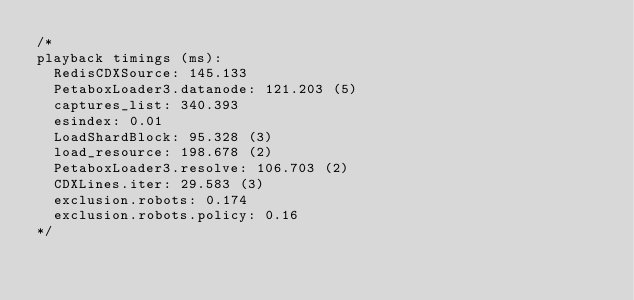Convert code to text. <code><loc_0><loc_0><loc_500><loc_500><_CSS_>/*
playback timings (ms):
  RedisCDXSource: 145.133
  PetaboxLoader3.datanode: 121.203 (5)
  captures_list: 340.393
  esindex: 0.01
  LoadShardBlock: 95.328 (3)
  load_resource: 198.678 (2)
  PetaboxLoader3.resolve: 106.703 (2)
  CDXLines.iter: 29.583 (3)
  exclusion.robots: 0.174
  exclusion.robots.policy: 0.16
*/</code> 